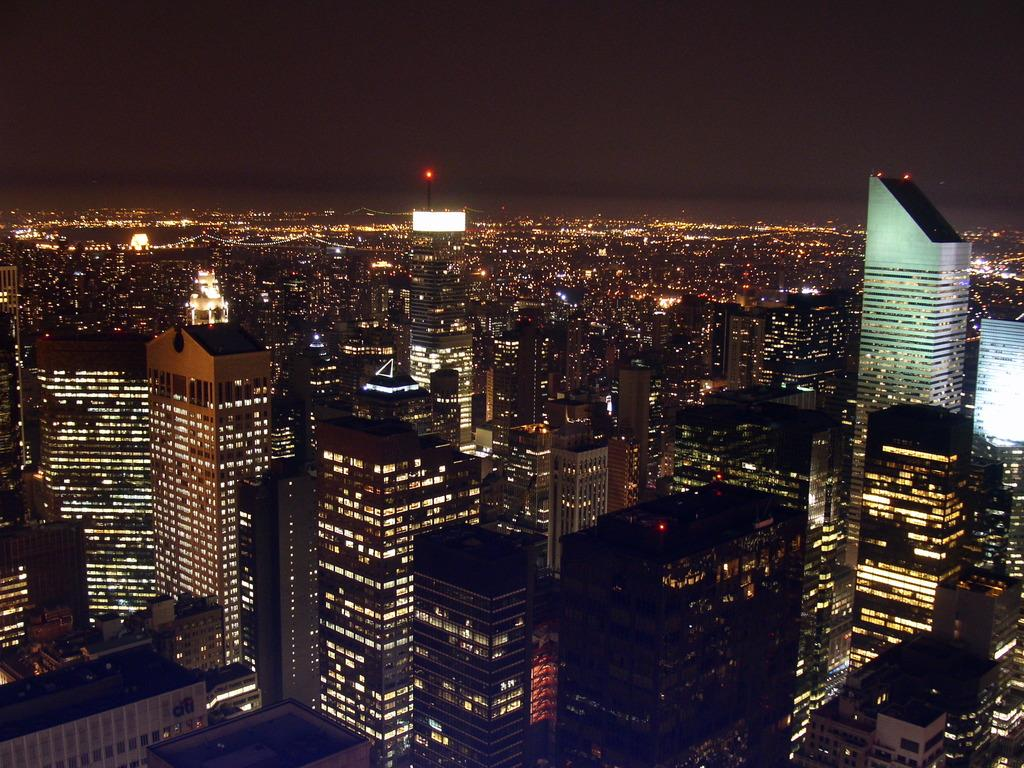What type of structures can be seen in the image? There are buildings in the image. What else is visible in the image besides the buildings? There are lights and the sky visible in the image. How many chairs are arranged in the image? There are no chairs present in the image. What date is marked on the calendar in the image? There is no calendar present in the image. 